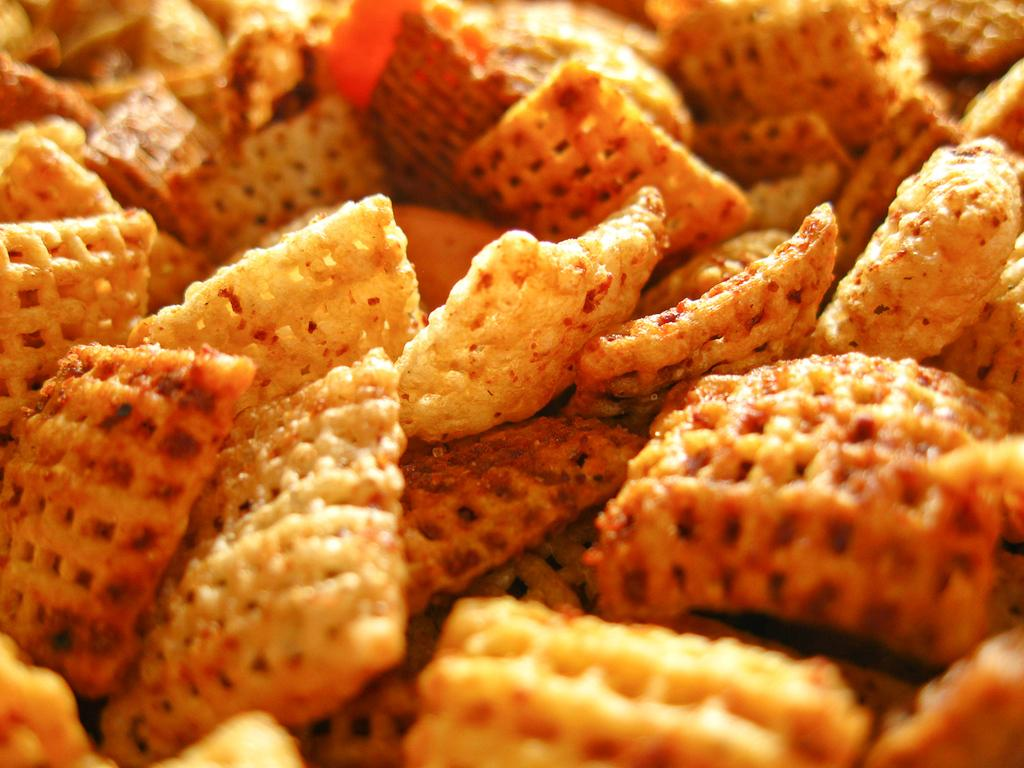What type of chips are featured in the image? There are spicy chips in the image. How are the spicy chips contained in the image? The spicy chips are in a red bucket. What type of fish can be seen swimming in the red bucket with the spicy chips? There are no fish present in the image; it only features spicy chips in a red bucket. 